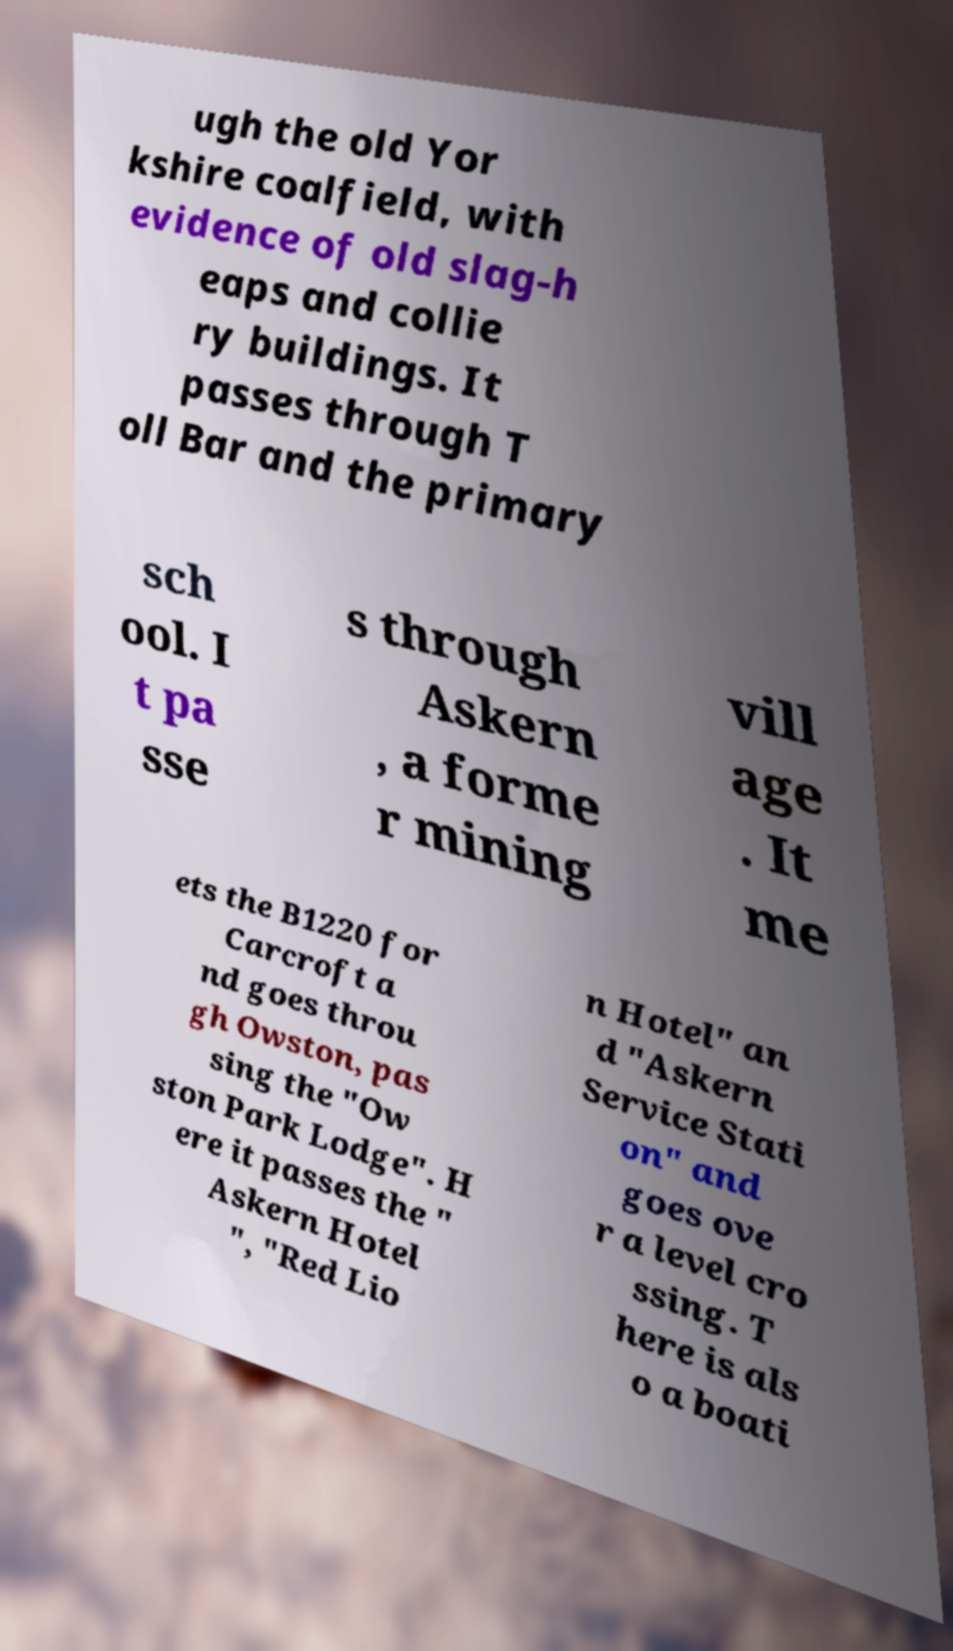Could you extract and type out the text from this image? ugh the old Yor kshire coalfield, with evidence of old slag-h eaps and collie ry buildings. It passes through T oll Bar and the primary sch ool. I t pa sse s through Askern , a forme r mining vill age . It me ets the B1220 for Carcroft a nd goes throu gh Owston, pas sing the "Ow ston Park Lodge". H ere it passes the " Askern Hotel ", "Red Lio n Hotel" an d "Askern Service Stati on" and goes ove r a level cro ssing. T here is als o a boati 